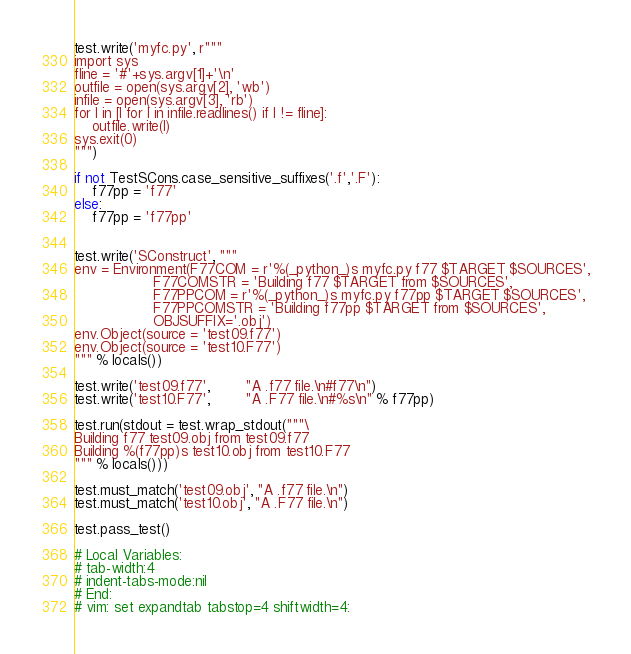<code> <loc_0><loc_0><loc_500><loc_500><_Python_>test.write('myfc.py', r"""
import sys
fline = '#'+sys.argv[1]+'\n'
outfile = open(sys.argv[2], 'wb')
infile = open(sys.argv[3], 'rb')
for l in [l for l in infile.readlines() if l != fline]:
    outfile.write(l)
sys.exit(0)
""")

if not TestSCons.case_sensitive_suffixes('.f','.F'):
    f77pp = 'f77'
else:
    f77pp = 'f77pp'


test.write('SConstruct', """
env = Environment(F77COM = r'%(_python_)s myfc.py f77 $TARGET $SOURCES',
                  F77COMSTR = 'Building f77 $TARGET from $SOURCES',
                  F77PPCOM = r'%(_python_)s myfc.py f77pp $TARGET $SOURCES',
                  F77PPCOMSTR = 'Building f77pp $TARGET from $SOURCES',
                  OBJSUFFIX='.obj')
env.Object(source = 'test09.f77')
env.Object(source = 'test10.F77')
""" % locals())

test.write('test09.f77',        "A .f77 file.\n#f77\n")
test.write('test10.F77',        "A .F77 file.\n#%s\n" % f77pp)

test.run(stdout = test.wrap_stdout("""\
Building f77 test09.obj from test09.f77
Building %(f77pp)s test10.obj from test10.F77
""" % locals()))

test.must_match('test09.obj', "A .f77 file.\n")
test.must_match('test10.obj', "A .F77 file.\n")

test.pass_test()

# Local Variables:
# tab-width:4
# indent-tabs-mode:nil
# End:
# vim: set expandtab tabstop=4 shiftwidth=4:
</code> 